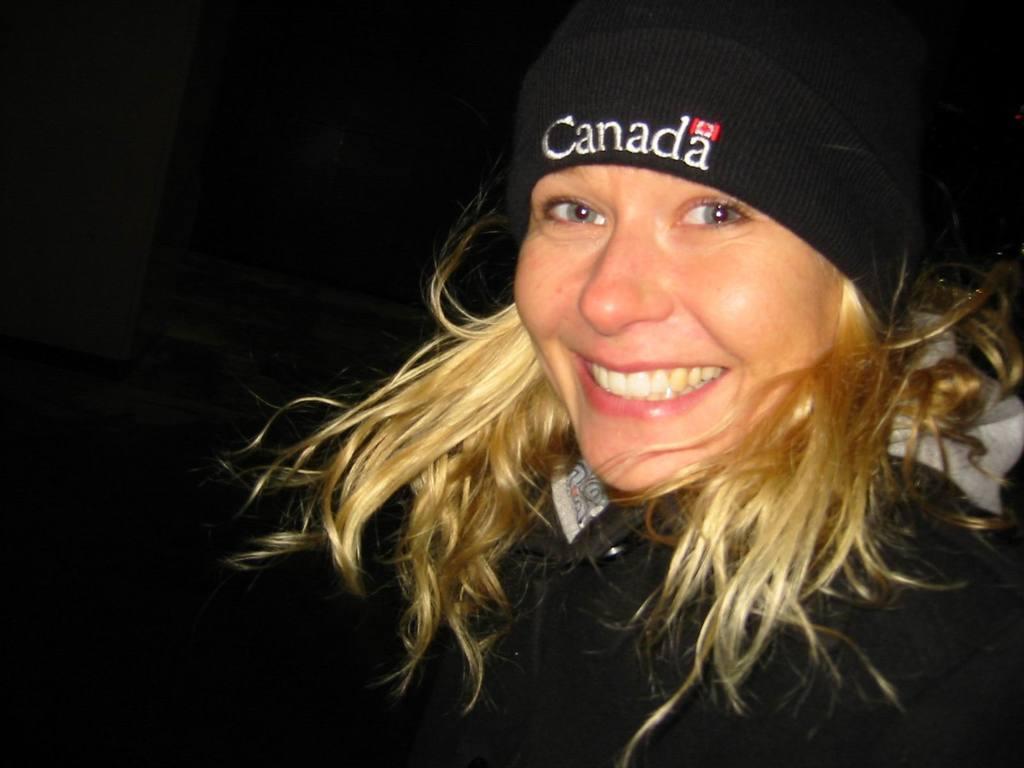Can you describe this image briefly? In this image we can see a person wearing black jacket and cap is smiling. The background of the image is dark. 